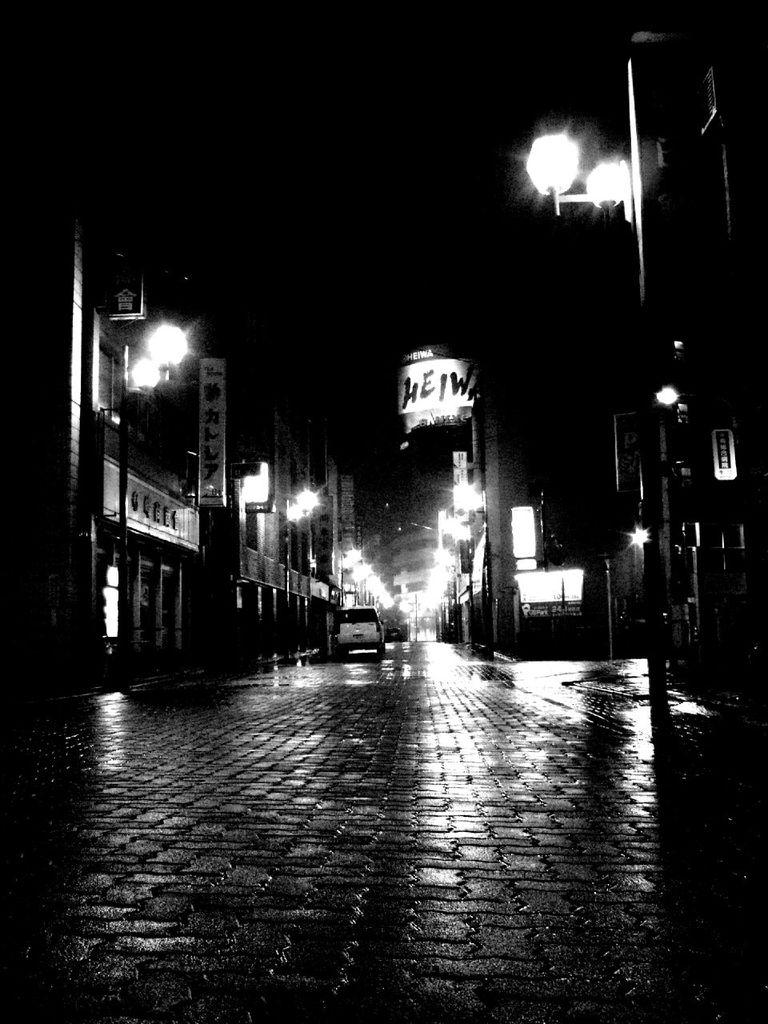What is the color scheme of the image? The image is black and white. What is an unusual object placement in the image? There is a car on the footpath in the image. What type of structures can be seen in the image? There are buildings with windows in the image. What are the boards on the buildings used for? The boards on the buildings might be used for advertisements or announcements. What are the street poles on the right side of the image used for? The street poles on the right side of the image might be used for street signs or lighting. Can you see the bear's eyes in the image? There is no bear present in the image, so it is not possible to see its eyes. 